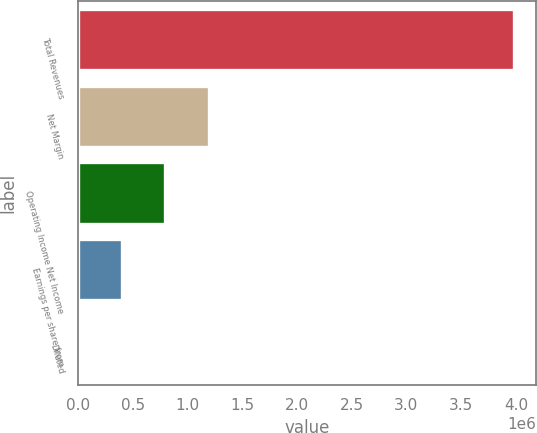Convert chart to OTSL. <chart><loc_0><loc_0><loc_500><loc_500><bar_chart><fcel>Total Revenues<fcel>Net Margin<fcel>Operating Income Net Income<fcel>Earnings per share from<fcel>Diluted<nl><fcel>3.98497e+06<fcel>1.19549e+06<fcel>796994<fcel>398498<fcel>0.98<nl></chart> 